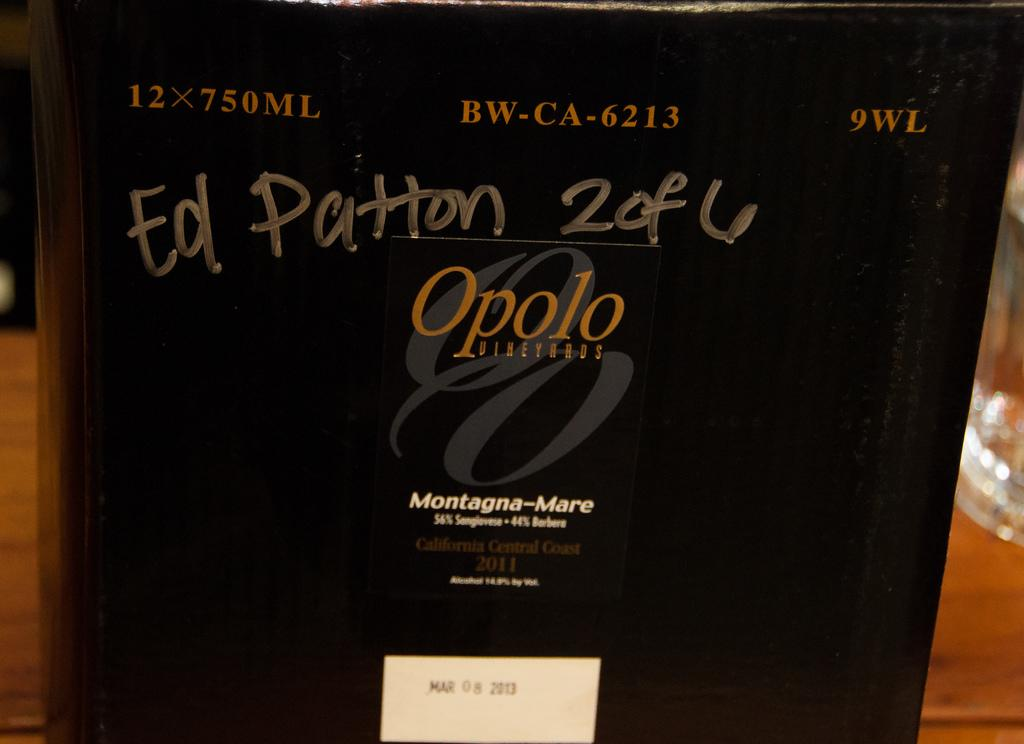Provide a one-sentence caption for the provided image. A large dark shaded bottle of Opolo wine in close up. 